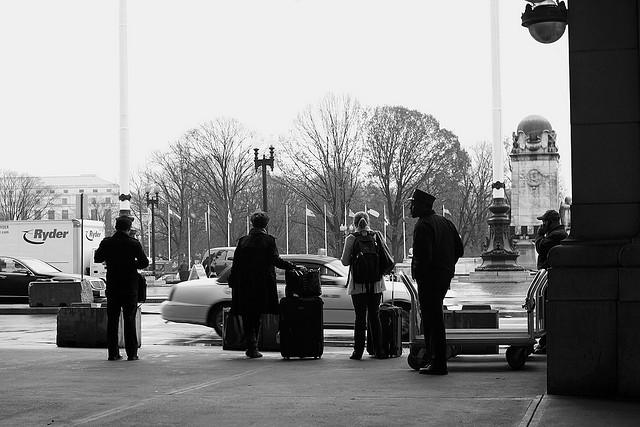What building did the people come from?

Choices:
A) hotel
B) train station
C) ferry terminal
D) airport airport 